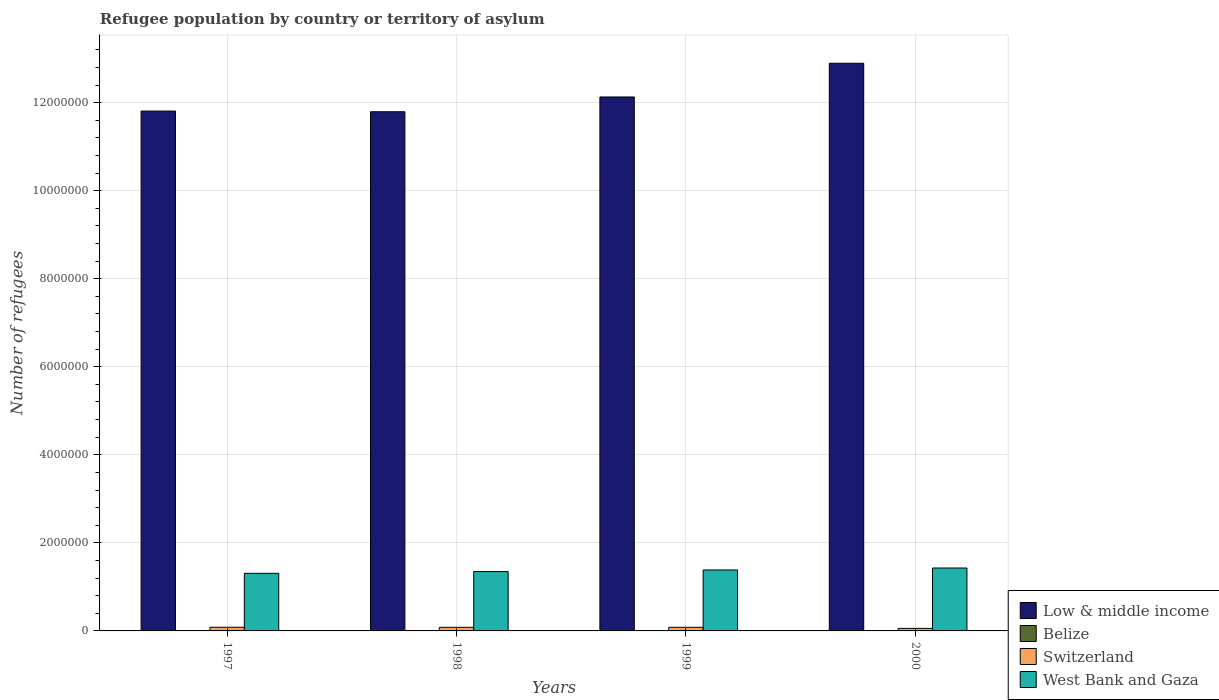How many groups of bars are there?
Make the answer very short. 4. In how many cases, is the number of bars for a given year not equal to the number of legend labels?
Keep it short and to the point. 0. What is the number of refugees in Low & middle income in 2000?
Your response must be concise. 1.29e+07. Across all years, what is the maximum number of refugees in Low & middle income?
Give a very brief answer. 1.29e+07. Across all years, what is the minimum number of refugees in Belize?
Ensure brevity in your answer.  1250. In which year was the number of refugees in West Bank and Gaza maximum?
Offer a terse response. 2000. What is the total number of refugees in West Bank and Gaza in the graph?
Your response must be concise. 5.47e+06. What is the difference between the number of refugees in Low & middle income in 1999 and that in 2000?
Your answer should be compact. -7.66e+05. What is the difference between the number of refugees in West Bank and Gaza in 2000 and the number of refugees in Switzerland in 1999?
Provide a short and direct response. 1.35e+06. What is the average number of refugees in Low & middle income per year?
Provide a short and direct response. 1.22e+07. In the year 2000, what is the difference between the number of refugees in Switzerland and number of refugees in Low & middle income?
Provide a succinct answer. -1.28e+07. What is the ratio of the number of refugees in Belize in 1999 to that in 2000?
Your response must be concise. 2.31. What is the difference between the highest and the second highest number of refugees in West Bank and Gaza?
Make the answer very short. 4.42e+04. What is the difference between the highest and the lowest number of refugees in West Bank and Gaza?
Give a very brief answer. 1.20e+05. In how many years, is the number of refugees in Low & middle income greater than the average number of refugees in Low & middle income taken over all years?
Offer a terse response. 1. What does the 2nd bar from the left in 2000 represents?
Offer a very short reply. Belize. What does the 3rd bar from the right in 1999 represents?
Keep it short and to the point. Belize. How many years are there in the graph?
Provide a short and direct response. 4. What is the difference between two consecutive major ticks on the Y-axis?
Ensure brevity in your answer.  2.00e+06. Does the graph contain any zero values?
Make the answer very short. No. Does the graph contain grids?
Your answer should be compact. Yes. Where does the legend appear in the graph?
Your answer should be compact. Bottom right. What is the title of the graph?
Offer a terse response. Refugee population by country or territory of asylum. Does "Latin America(all income levels)" appear as one of the legend labels in the graph?
Your answer should be very brief. No. What is the label or title of the Y-axis?
Keep it short and to the point. Number of refugees. What is the Number of refugees in Low & middle income in 1997?
Give a very brief answer. 1.18e+07. What is the Number of refugees of Belize in 1997?
Keep it short and to the point. 8387. What is the Number of refugees of Switzerland in 1997?
Provide a short and direct response. 8.32e+04. What is the Number of refugees in West Bank and Gaza in 1997?
Keep it short and to the point. 1.31e+06. What is the Number of refugees of Low & middle income in 1998?
Provide a short and direct response. 1.18e+07. What is the Number of refugees in Belize in 1998?
Give a very brief answer. 3483. What is the Number of refugees in Switzerland in 1998?
Your answer should be compact. 8.19e+04. What is the Number of refugees of West Bank and Gaza in 1998?
Make the answer very short. 1.35e+06. What is the Number of refugees of Low & middle income in 1999?
Offer a very short reply. 1.21e+07. What is the Number of refugees in Belize in 1999?
Provide a succinct answer. 2891. What is the Number of refugees of Switzerland in 1999?
Provide a succinct answer. 8.23e+04. What is the Number of refugees of West Bank and Gaza in 1999?
Keep it short and to the point. 1.38e+06. What is the Number of refugees of Low & middle income in 2000?
Give a very brief answer. 1.29e+07. What is the Number of refugees of Belize in 2000?
Your response must be concise. 1250. What is the Number of refugees of Switzerland in 2000?
Provide a succinct answer. 5.77e+04. What is the Number of refugees in West Bank and Gaza in 2000?
Make the answer very short. 1.43e+06. Across all years, what is the maximum Number of refugees in Low & middle income?
Ensure brevity in your answer.  1.29e+07. Across all years, what is the maximum Number of refugees in Belize?
Offer a very short reply. 8387. Across all years, what is the maximum Number of refugees in Switzerland?
Make the answer very short. 8.32e+04. Across all years, what is the maximum Number of refugees in West Bank and Gaza?
Give a very brief answer. 1.43e+06. Across all years, what is the minimum Number of refugees in Low & middle income?
Your response must be concise. 1.18e+07. Across all years, what is the minimum Number of refugees of Belize?
Make the answer very short. 1250. Across all years, what is the minimum Number of refugees in Switzerland?
Your answer should be compact. 5.77e+04. Across all years, what is the minimum Number of refugees of West Bank and Gaza?
Your answer should be very brief. 1.31e+06. What is the total Number of refugees of Low & middle income in the graph?
Offer a very short reply. 4.86e+07. What is the total Number of refugees in Belize in the graph?
Provide a short and direct response. 1.60e+04. What is the total Number of refugees in Switzerland in the graph?
Your answer should be very brief. 3.05e+05. What is the total Number of refugees of West Bank and Gaza in the graph?
Offer a terse response. 5.47e+06. What is the difference between the Number of refugees in Low & middle income in 1997 and that in 1998?
Give a very brief answer. 1.51e+04. What is the difference between the Number of refugees in Belize in 1997 and that in 1998?
Give a very brief answer. 4904. What is the difference between the Number of refugees of Switzerland in 1997 and that in 1998?
Make the answer very short. 1300. What is the difference between the Number of refugees in West Bank and Gaza in 1997 and that in 1998?
Provide a short and direct response. -3.98e+04. What is the difference between the Number of refugees of Low & middle income in 1997 and that in 1999?
Provide a short and direct response. -3.20e+05. What is the difference between the Number of refugees in Belize in 1997 and that in 1999?
Provide a short and direct response. 5496. What is the difference between the Number of refugees of Switzerland in 1997 and that in 1999?
Make the answer very short. 905. What is the difference between the Number of refugees in West Bank and Gaza in 1997 and that in 1999?
Your answer should be compact. -7.62e+04. What is the difference between the Number of refugees in Low & middle income in 1997 and that in 2000?
Your response must be concise. -1.09e+06. What is the difference between the Number of refugees in Belize in 1997 and that in 2000?
Provide a succinct answer. 7137. What is the difference between the Number of refugees in Switzerland in 1997 and that in 2000?
Your answer should be compact. 2.56e+04. What is the difference between the Number of refugees of West Bank and Gaza in 1997 and that in 2000?
Provide a short and direct response. -1.20e+05. What is the difference between the Number of refugees in Low & middle income in 1998 and that in 1999?
Provide a succinct answer. -3.35e+05. What is the difference between the Number of refugees in Belize in 1998 and that in 1999?
Provide a short and direct response. 592. What is the difference between the Number of refugees in Switzerland in 1998 and that in 1999?
Offer a very short reply. -395. What is the difference between the Number of refugees in West Bank and Gaza in 1998 and that in 1999?
Offer a terse response. -3.64e+04. What is the difference between the Number of refugees of Low & middle income in 1998 and that in 2000?
Your response must be concise. -1.10e+06. What is the difference between the Number of refugees of Belize in 1998 and that in 2000?
Make the answer very short. 2233. What is the difference between the Number of refugees of Switzerland in 1998 and that in 2000?
Give a very brief answer. 2.42e+04. What is the difference between the Number of refugees of West Bank and Gaza in 1998 and that in 2000?
Offer a very short reply. -8.06e+04. What is the difference between the Number of refugees in Low & middle income in 1999 and that in 2000?
Your answer should be very brief. -7.66e+05. What is the difference between the Number of refugees of Belize in 1999 and that in 2000?
Provide a succinct answer. 1641. What is the difference between the Number of refugees of Switzerland in 1999 and that in 2000?
Provide a succinct answer. 2.46e+04. What is the difference between the Number of refugees of West Bank and Gaza in 1999 and that in 2000?
Give a very brief answer. -4.42e+04. What is the difference between the Number of refugees in Low & middle income in 1997 and the Number of refugees in Belize in 1998?
Ensure brevity in your answer.  1.18e+07. What is the difference between the Number of refugees of Low & middle income in 1997 and the Number of refugees of Switzerland in 1998?
Offer a very short reply. 1.17e+07. What is the difference between the Number of refugees in Low & middle income in 1997 and the Number of refugees in West Bank and Gaza in 1998?
Make the answer very short. 1.05e+07. What is the difference between the Number of refugees in Belize in 1997 and the Number of refugees in Switzerland in 1998?
Make the answer very short. -7.35e+04. What is the difference between the Number of refugees in Belize in 1997 and the Number of refugees in West Bank and Gaza in 1998?
Your answer should be compact. -1.34e+06. What is the difference between the Number of refugees of Switzerland in 1997 and the Number of refugees of West Bank and Gaza in 1998?
Your answer should be compact. -1.27e+06. What is the difference between the Number of refugees of Low & middle income in 1997 and the Number of refugees of Belize in 1999?
Offer a terse response. 1.18e+07. What is the difference between the Number of refugees in Low & middle income in 1997 and the Number of refugees in Switzerland in 1999?
Your answer should be compact. 1.17e+07. What is the difference between the Number of refugees in Low & middle income in 1997 and the Number of refugees in West Bank and Gaza in 1999?
Make the answer very short. 1.04e+07. What is the difference between the Number of refugees of Belize in 1997 and the Number of refugees of Switzerland in 1999?
Keep it short and to the point. -7.39e+04. What is the difference between the Number of refugees in Belize in 1997 and the Number of refugees in West Bank and Gaza in 1999?
Keep it short and to the point. -1.38e+06. What is the difference between the Number of refugees of Switzerland in 1997 and the Number of refugees of West Bank and Gaza in 1999?
Make the answer very short. -1.30e+06. What is the difference between the Number of refugees in Low & middle income in 1997 and the Number of refugees in Belize in 2000?
Ensure brevity in your answer.  1.18e+07. What is the difference between the Number of refugees of Low & middle income in 1997 and the Number of refugees of Switzerland in 2000?
Your answer should be very brief. 1.18e+07. What is the difference between the Number of refugees of Low & middle income in 1997 and the Number of refugees of West Bank and Gaza in 2000?
Keep it short and to the point. 1.04e+07. What is the difference between the Number of refugees in Belize in 1997 and the Number of refugees in Switzerland in 2000?
Your response must be concise. -4.93e+04. What is the difference between the Number of refugees of Belize in 1997 and the Number of refugees of West Bank and Gaza in 2000?
Give a very brief answer. -1.42e+06. What is the difference between the Number of refugees of Switzerland in 1997 and the Number of refugees of West Bank and Gaza in 2000?
Provide a short and direct response. -1.35e+06. What is the difference between the Number of refugees in Low & middle income in 1998 and the Number of refugees in Belize in 1999?
Offer a very short reply. 1.18e+07. What is the difference between the Number of refugees in Low & middle income in 1998 and the Number of refugees in Switzerland in 1999?
Your answer should be compact. 1.17e+07. What is the difference between the Number of refugees of Low & middle income in 1998 and the Number of refugees of West Bank and Gaza in 1999?
Offer a very short reply. 1.04e+07. What is the difference between the Number of refugees of Belize in 1998 and the Number of refugees of Switzerland in 1999?
Make the answer very short. -7.88e+04. What is the difference between the Number of refugees in Belize in 1998 and the Number of refugees in West Bank and Gaza in 1999?
Your response must be concise. -1.38e+06. What is the difference between the Number of refugees of Switzerland in 1998 and the Number of refugees of West Bank and Gaza in 1999?
Provide a short and direct response. -1.30e+06. What is the difference between the Number of refugees of Low & middle income in 1998 and the Number of refugees of Belize in 2000?
Offer a terse response. 1.18e+07. What is the difference between the Number of refugees in Low & middle income in 1998 and the Number of refugees in Switzerland in 2000?
Offer a very short reply. 1.17e+07. What is the difference between the Number of refugees of Low & middle income in 1998 and the Number of refugees of West Bank and Gaza in 2000?
Offer a terse response. 1.04e+07. What is the difference between the Number of refugees in Belize in 1998 and the Number of refugees in Switzerland in 2000?
Provide a succinct answer. -5.42e+04. What is the difference between the Number of refugees of Belize in 1998 and the Number of refugees of West Bank and Gaza in 2000?
Provide a succinct answer. -1.43e+06. What is the difference between the Number of refugees of Switzerland in 1998 and the Number of refugees of West Bank and Gaza in 2000?
Offer a terse response. -1.35e+06. What is the difference between the Number of refugees of Low & middle income in 1999 and the Number of refugees of Belize in 2000?
Make the answer very short. 1.21e+07. What is the difference between the Number of refugees in Low & middle income in 1999 and the Number of refugees in Switzerland in 2000?
Your answer should be compact. 1.21e+07. What is the difference between the Number of refugees of Low & middle income in 1999 and the Number of refugees of West Bank and Gaza in 2000?
Ensure brevity in your answer.  1.07e+07. What is the difference between the Number of refugees of Belize in 1999 and the Number of refugees of Switzerland in 2000?
Make the answer very short. -5.48e+04. What is the difference between the Number of refugees of Belize in 1999 and the Number of refugees of West Bank and Gaza in 2000?
Make the answer very short. -1.43e+06. What is the difference between the Number of refugees of Switzerland in 1999 and the Number of refugees of West Bank and Gaza in 2000?
Your answer should be compact. -1.35e+06. What is the average Number of refugees of Low & middle income per year?
Your response must be concise. 1.22e+07. What is the average Number of refugees of Belize per year?
Offer a terse response. 4002.75. What is the average Number of refugees in Switzerland per year?
Your answer should be compact. 7.63e+04. What is the average Number of refugees of West Bank and Gaza per year?
Keep it short and to the point. 1.37e+06. In the year 1997, what is the difference between the Number of refugees in Low & middle income and Number of refugees in Belize?
Provide a short and direct response. 1.18e+07. In the year 1997, what is the difference between the Number of refugees of Low & middle income and Number of refugees of Switzerland?
Your response must be concise. 1.17e+07. In the year 1997, what is the difference between the Number of refugees in Low & middle income and Number of refugees in West Bank and Gaza?
Your response must be concise. 1.05e+07. In the year 1997, what is the difference between the Number of refugees in Belize and Number of refugees in Switzerland?
Provide a succinct answer. -7.48e+04. In the year 1997, what is the difference between the Number of refugees of Belize and Number of refugees of West Bank and Gaza?
Offer a very short reply. -1.30e+06. In the year 1997, what is the difference between the Number of refugees in Switzerland and Number of refugees in West Bank and Gaza?
Make the answer very short. -1.23e+06. In the year 1998, what is the difference between the Number of refugees in Low & middle income and Number of refugees in Belize?
Provide a short and direct response. 1.18e+07. In the year 1998, what is the difference between the Number of refugees in Low & middle income and Number of refugees in Switzerland?
Keep it short and to the point. 1.17e+07. In the year 1998, what is the difference between the Number of refugees in Low & middle income and Number of refugees in West Bank and Gaza?
Provide a succinct answer. 1.04e+07. In the year 1998, what is the difference between the Number of refugees of Belize and Number of refugees of Switzerland?
Give a very brief answer. -7.84e+04. In the year 1998, what is the difference between the Number of refugees in Belize and Number of refugees in West Bank and Gaza?
Provide a short and direct response. -1.34e+06. In the year 1998, what is the difference between the Number of refugees of Switzerland and Number of refugees of West Bank and Gaza?
Offer a terse response. -1.27e+06. In the year 1999, what is the difference between the Number of refugees in Low & middle income and Number of refugees in Belize?
Make the answer very short. 1.21e+07. In the year 1999, what is the difference between the Number of refugees in Low & middle income and Number of refugees in Switzerland?
Offer a very short reply. 1.20e+07. In the year 1999, what is the difference between the Number of refugees in Low & middle income and Number of refugees in West Bank and Gaza?
Make the answer very short. 1.07e+07. In the year 1999, what is the difference between the Number of refugees in Belize and Number of refugees in Switzerland?
Your answer should be compact. -7.94e+04. In the year 1999, what is the difference between the Number of refugees of Belize and Number of refugees of West Bank and Gaza?
Offer a terse response. -1.38e+06. In the year 1999, what is the difference between the Number of refugees in Switzerland and Number of refugees in West Bank and Gaza?
Offer a very short reply. -1.30e+06. In the year 2000, what is the difference between the Number of refugees in Low & middle income and Number of refugees in Belize?
Provide a short and direct response. 1.29e+07. In the year 2000, what is the difference between the Number of refugees in Low & middle income and Number of refugees in Switzerland?
Provide a succinct answer. 1.28e+07. In the year 2000, what is the difference between the Number of refugees in Low & middle income and Number of refugees in West Bank and Gaza?
Provide a short and direct response. 1.15e+07. In the year 2000, what is the difference between the Number of refugees in Belize and Number of refugees in Switzerland?
Your answer should be compact. -5.64e+04. In the year 2000, what is the difference between the Number of refugees of Belize and Number of refugees of West Bank and Gaza?
Your response must be concise. -1.43e+06. In the year 2000, what is the difference between the Number of refugees in Switzerland and Number of refugees in West Bank and Gaza?
Make the answer very short. -1.37e+06. What is the ratio of the Number of refugees of Low & middle income in 1997 to that in 1998?
Ensure brevity in your answer.  1. What is the ratio of the Number of refugees of Belize in 1997 to that in 1998?
Make the answer very short. 2.41. What is the ratio of the Number of refugees of Switzerland in 1997 to that in 1998?
Your answer should be very brief. 1.02. What is the ratio of the Number of refugees in West Bank and Gaza in 1997 to that in 1998?
Offer a very short reply. 0.97. What is the ratio of the Number of refugees of Low & middle income in 1997 to that in 1999?
Offer a terse response. 0.97. What is the ratio of the Number of refugees in Belize in 1997 to that in 1999?
Your answer should be compact. 2.9. What is the ratio of the Number of refugees in Switzerland in 1997 to that in 1999?
Ensure brevity in your answer.  1.01. What is the ratio of the Number of refugees in West Bank and Gaza in 1997 to that in 1999?
Offer a terse response. 0.94. What is the ratio of the Number of refugees of Low & middle income in 1997 to that in 2000?
Your answer should be compact. 0.92. What is the ratio of the Number of refugees in Belize in 1997 to that in 2000?
Your answer should be compact. 6.71. What is the ratio of the Number of refugees of Switzerland in 1997 to that in 2000?
Keep it short and to the point. 1.44. What is the ratio of the Number of refugees of West Bank and Gaza in 1997 to that in 2000?
Offer a very short reply. 0.92. What is the ratio of the Number of refugees in Low & middle income in 1998 to that in 1999?
Ensure brevity in your answer.  0.97. What is the ratio of the Number of refugees of Belize in 1998 to that in 1999?
Your answer should be compact. 1.2. What is the ratio of the Number of refugees of Switzerland in 1998 to that in 1999?
Keep it short and to the point. 1. What is the ratio of the Number of refugees of West Bank and Gaza in 1998 to that in 1999?
Make the answer very short. 0.97. What is the ratio of the Number of refugees of Low & middle income in 1998 to that in 2000?
Make the answer very short. 0.91. What is the ratio of the Number of refugees in Belize in 1998 to that in 2000?
Your response must be concise. 2.79. What is the ratio of the Number of refugees in Switzerland in 1998 to that in 2000?
Provide a short and direct response. 1.42. What is the ratio of the Number of refugees in West Bank and Gaza in 1998 to that in 2000?
Offer a terse response. 0.94. What is the ratio of the Number of refugees in Low & middle income in 1999 to that in 2000?
Offer a terse response. 0.94. What is the ratio of the Number of refugees of Belize in 1999 to that in 2000?
Make the answer very short. 2.31. What is the ratio of the Number of refugees of Switzerland in 1999 to that in 2000?
Your response must be concise. 1.43. What is the difference between the highest and the second highest Number of refugees of Low & middle income?
Make the answer very short. 7.66e+05. What is the difference between the highest and the second highest Number of refugees in Belize?
Your response must be concise. 4904. What is the difference between the highest and the second highest Number of refugees in Switzerland?
Make the answer very short. 905. What is the difference between the highest and the second highest Number of refugees of West Bank and Gaza?
Ensure brevity in your answer.  4.42e+04. What is the difference between the highest and the lowest Number of refugees of Low & middle income?
Offer a terse response. 1.10e+06. What is the difference between the highest and the lowest Number of refugees in Belize?
Offer a very short reply. 7137. What is the difference between the highest and the lowest Number of refugees of Switzerland?
Provide a succinct answer. 2.56e+04. What is the difference between the highest and the lowest Number of refugees in West Bank and Gaza?
Keep it short and to the point. 1.20e+05. 